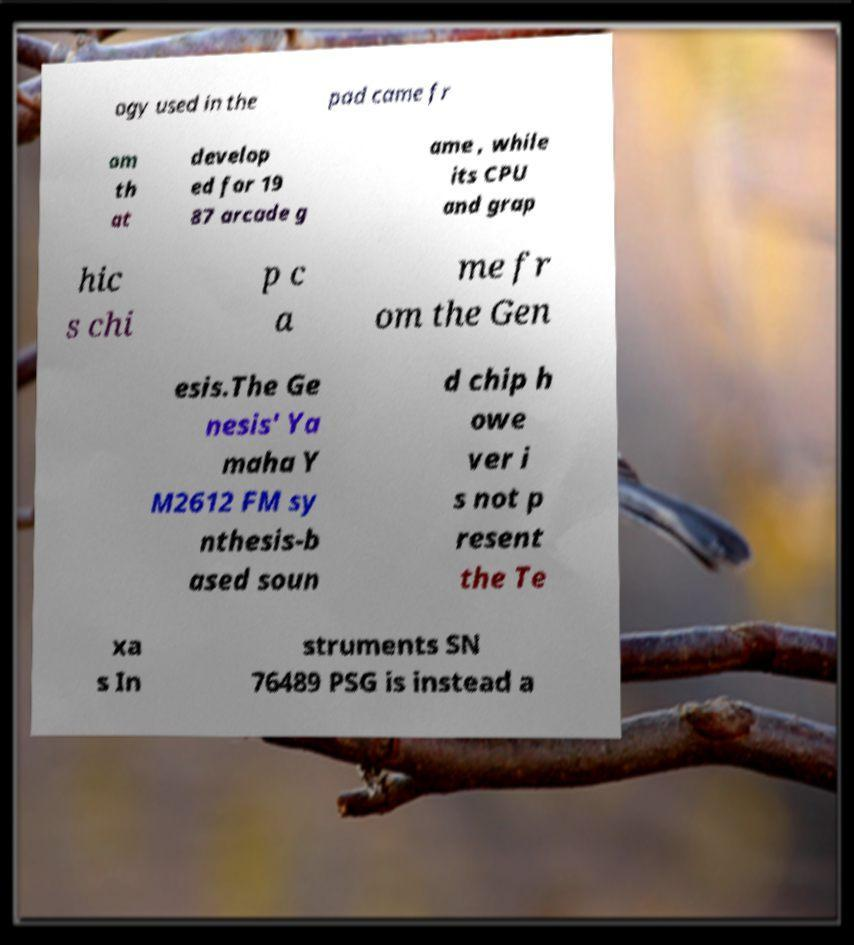For documentation purposes, I need the text within this image transcribed. Could you provide that? ogy used in the pad came fr om th at develop ed for 19 87 arcade g ame , while its CPU and grap hic s chi p c a me fr om the Gen esis.The Ge nesis' Ya maha Y M2612 FM sy nthesis-b ased soun d chip h owe ver i s not p resent the Te xa s In struments SN 76489 PSG is instead a 